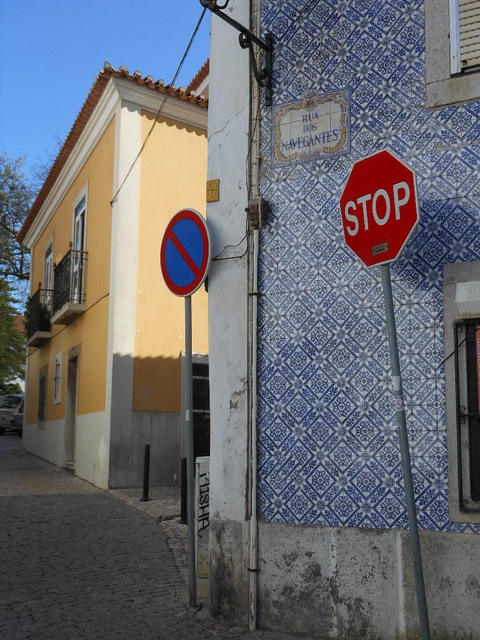Describe the objects in this image and their specific colors. I can see a stop sign in gray, maroon, and darkgray tones in this image. 